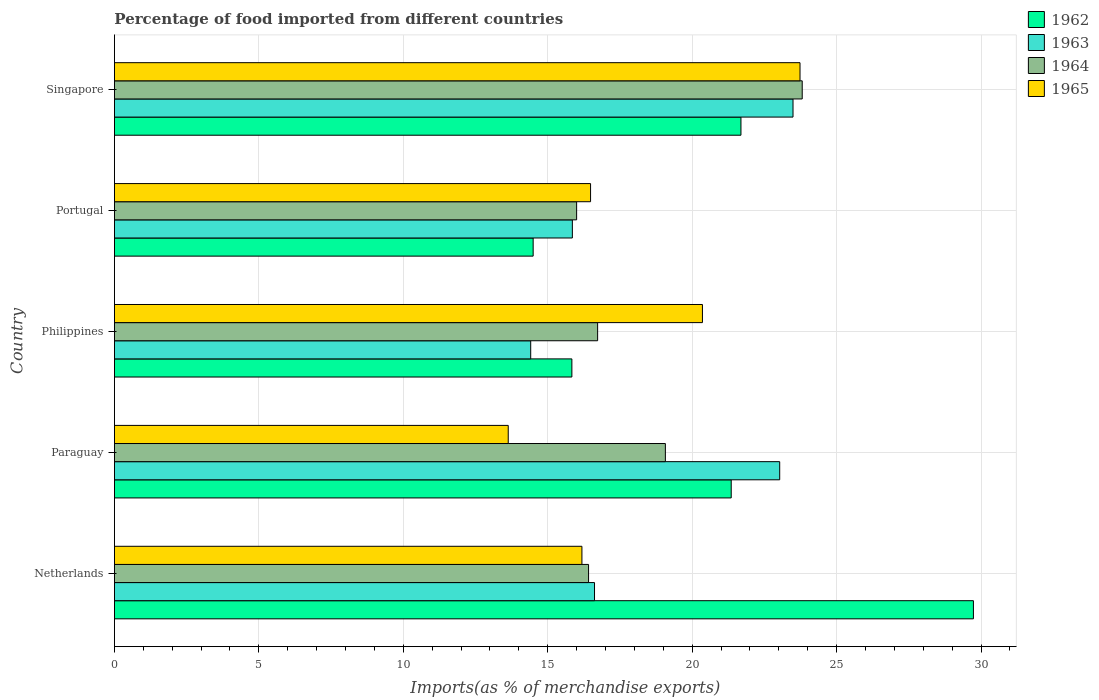How many different coloured bars are there?
Keep it short and to the point. 4. Are the number of bars per tick equal to the number of legend labels?
Offer a terse response. Yes. How many bars are there on the 4th tick from the bottom?
Provide a short and direct response. 4. In how many cases, is the number of bars for a given country not equal to the number of legend labels?
Your response must be concise. 0. What is the percentage of imports to different countries in 1964 in Netherlands?
Ensure brevity in your answer.  16.41. Across all countries, what is the maximum percentage of imports to different countries in 1965?
Offer a very short reply. 23.73. Across all countries, what is the minimum percentage of imports to different countries in 1964?
Ensure brevity in your answer.  16. In which country was the percentage of imports to different countries in 1963 maximum?
Give a very brief answer. Singapore. What is the total percentage of imports to different countries in 1964 in the graph?
Your answer should be compact. 92.02. What is the difference between the percentage of imports to different countries in 1962 in Paraguay and that in Portugal?
Your response must be concise. 6.86. What is the difference between the percentage of imports to different countries in 1965 in Paraguay and the percentage of imports to different countries in 1964 in Philippines?
Keep it short and to the point. -3.09. What is the average percentage of imports to different countries in 1964 per country?
Give a very brief answer. 18.4. What is the difference between the percentage of imports to different countries in 1964 and percentage of imports to different countries in 1965 in Netherlands?
Give a very brief answer. 0.23. What is the ratio of the percentage of imports to different countries in 1965 in Portugal to that in Singapore?
Offer a very short reply. 0.69. Is the difference between the percentage of imports to different countries in 1964 in Philippines and Portugal greater than the difference between the percentage of imports to different countries in 1965 in Philippines and Portugal?
Offer a terse response. No. What is the difference between the highest and the second highest percentage of imports to different countries in 1964?
Ensure brevity in your answer.  4.74. What is the difference between the highest and the lowest percentage of imports to different countries in 1965?
Provide a short and direct response. 10.1. Is the sum of the percentage of imports to different countries in 1965 in Netherlands and Portugal greater than the maximum percentage of imports to different countries in 1963 across all countries?
Provide a succinct answer. Yes. What does the 1st bar from the top in Portugal represents?
Your response must be concise. 1965. What does the 4th bar from the bottom in Singapore represents?
Your answer should be compact. 1965. Is it the case that in every country, the sum of the percentage of imports to different countries in 1964 and percentage of imports to different countries in 1965 is greater than the percentage of imports to different countries in 1962?
Offer a very short reply. Yes. Are all the bars in the graph horizontal?
Provide a short and direct response. Yes. Are the values on the major ticks of X-axis written in scientific E-notation?
Offer a very short reply. No. Does the graph contain any zero values?
Your answer should be very brief. No. Does the graph contain grids?
Provide a short and direct response. Yes. Where does the legend appear in the graph?
Provide a short and direct response. Top right. How many legend labels are there?
Give a very brief answer. 4. How are the legend labels stacked?
Provide a short and direct response. Vertical. What is the title of the graph?
Provide a short and direct response. Percentage of food imported from different countries. What is the label or title of the X-axis?
Ensure brevity in your answer.  Imports(as % of merchandise exports). What is the label or title of the Y-axis?
Give a very brief answer. Country. What is the Imports(as % of merchandise exports) in 1962 in Netherlands?
Ensure brevity in your answer.  29.73. What is the Imports(as % of merchandise exports) in 1963 in Netherlands?
Provide a short and direct response. 16.62. What is the Imports(as % of merchandise exports) of 1964 in Netherlands?
Keep it short and to the point. 16.41. What is the Imports(as % of merchandise exports) in 1965 in Netherlands?
Keep it short and to the point. 16.18. What is the Imports(as % of merchandise exports) in 1962 in Paraguay?
Your answer should be very brief. 21.35. What is the Imports(as % of merchandise exports) in 1963 in Paraguay?
Make the answer very short. 23.03. What is the Imports(as % of merchandise exports) of 1964 in Paraguay?
Provide a succinct answer. 19.07. What is the Imports(as % of merchandise exports) in 1965 in Paraguay?
Give a very brief answer. 13.63. What is the Imports(as % of merchandise exports) in 1962 in Philippines?
Your answer should be very brief. 15.83. What is the Imports(as % of merchandise exports) in 1963 in Philippines?
Offer a terse response. 14.41. What is the Imports(as % of merchandise exports) of 1964 in Philippines?
Your answer should be very brief. 16.73. What is the Imports(as % of merchandise exports) of 1965 in Philippines?
Give a very brief answer. 20.35. What is the Imports(as % of merchandise exports) in 1962 in Portugal?
Your answer should be compact. 14.49. What is the Imports(as % of merchandise exports) of 1963 in Portugal?
Provide a succinct answer. 15.85. What is the Imports(as % of merchandise exports) of 1964 in Portugal?
Your answer should be very brief. 16. What is the Imports(as % of merchandise exports) in 1965 in Portugal?
Your answer should be compact. 16.48. What is the Imports(as % of merchandise exports) in 1962 in Singapore?
Provide a short and direct response. 21.69. What is the Imports(as % of merchandise exports) in 1963 in Singapore?
Ensure brevity in your answer.  23.49. What is the Imports(as % of merchandise exports) of 1964 in Singapore?
Your answer should be very brief. 23.81. What is the Imports(as % of merchandise exports) in 1965 in Singapore?
Offer a terse response. 23.73. Across all countries, what is the maximum Imports(as % of merchandise exports) of 1962?
Provide a succinct answer. 29.73. Across all countries, what is the maximum Imports(as % of merchandise exports) of 1963?
Offer a very short reply. 23.49. Across all countries, what is the maximum Imports(as % of merchandise exports) of 1964?
Offer a very short reply. 23.81. Across all countries, what is the maximum Imports(as % of merchandise exports) in 1965?
Keep it short and to the point. 23.73. Across all countries, what is the minimum Imports(as % of merchandise exports) of 1962?
Your response must be concise. 14.49. Across all countries, what is the minimum Imports(as % of merchandise exports) of 1963?
Give a very brief answer. 14.41. Across all countries, what is the minimum Imports(as % of merchandise exports) of 1964?
Give a very brief answer. 16. Across all countries, what is the minimum Imports(as % of merchandise exports) in 1965?
Keep it short and to the point. 13.63. What is the total Imports(as % of merchandise exports) of 1962 in the graph?
Your answer should be very brief. 103.1. What is the total Imports(as % of merchandise exports) in 1963 in the graph?
Provide a short and direct response. 93.4. What is the total Imports(as % of merchandise exports) in 1964 in the graph?
Give a very brief answer. 92.02. What is the total Imports(as % of merchandise exports) in 1965 in the graph?
Offer a terse response. 90.38. What is the difference between the Imports(as % of merchandise exports) of 1962 in Netherlands and that in Paraguay?
Give a very brief answer. 8.38. What is the difference between the Imports(as % of merchandise exports) in 1963 in Netherlands and that in Paraguay?
Ensure brevity in your answer.  -6.41. What is the difference between the Imports(as % of merchandise exports) of 1964 in Netherlands and that in Paraguay?
Provide a succinct answer. -2.66. What is the difference between the Imports(as % of merchandise exports) of 1965 in Netherlands and that in Paraguay?
Offer a very short reply. 2.55. What is the difference between the Imports(as % of merchandise exports) of 1962 in Netherlands and that in Philippines?
Give a very brief answer. 13.9. What is the difference between the Imports(as % of merchandise exports) in 1963 in Netherlands and that in Philippines?
Your answer should be compact. 2.21. What is the difference between the Imports(as % of merchandise exports) of 1964 in Netherlands and that in Philippines?
Provide a succinct answer. -0.31. What is the difference between the Imports(as % of merchandise exports) in 1965 in Netherlands and that in Philippines?
Offer a very short reply. -4.17. What is the difference between the Imports(as % of merchandise exports) in 1962 in Netherlands and that in Portugal?
Provide a short and direct response. 15.24. What is the difference between the Imports(as % of merchandise exports) in 1963 in Netherlands and that in Portugal?
Make the answer very short. 0.77. What is the difference between the Imports(as % of merchandise exports) of 1964 in Netherlands and that in Portugal?
Provide a succinct answer. 0.41. What is the difference between the Imports(as % of merchandise exports) in 1965 in Netherlands and that in Portugal?
Your answer should be compact. -0.3. What is the difference between the Imports(as % of merchandise exports) in 1962 in Netherlands and that in Singapore?
Provide a short and direct response. 8.05. What is the difference between the Imports(as % of merchandise exports) in 1963 in Netherlands and that in Singapore?
Provide a short and direct response. -6.87. What is the difference between the Imports(as % of merchandise exports) in 1964 in Netherlands and that in Singapore?
Your answer should be compact. -7.4. What is the difference between the Imports(as % of merchandise exports) in 1965 in Netherlands and that in Singapore?
Your answer should be very brief. -7.55. What is the difference between the Imports(as % of merchandise exports) of 1962 in Paraguay and that in Philippines?
Offer a terse response. 5.52. What is the difference between the Imports(as % of merchandise exports) of 1963 in Paraguay and that in Philippines?
Keep it short and to the point. 8.62. What is the difference between the Imports(as % of merchandise exports) of 1964 in Paraguay and that in Philippines?
Your response must be concise. 2.35. What is the difference between the Imports(as % of merchandise exports) in 1965 in Paraguay and that in Philippines?
Keep it short and to the point. -6.72. What is the difference between the Imports(as % of merchandise exports) in 1962 in Paraguay and that in Portugal?
Ensure brevity in your answer.  6.86. What is the difference between the Imports(as % of merchandise exports) of 1963 in Paraguay and that in Portugal?
Offer a terse response. 7.18. What is the difference between the Imports(as % of merchandise exports) of 1964 in Paraguay and that in Portugal?
Provide a succinct answer. 3.07. What is the difference between the Imports(as % of merchandise exports) of 1965 in Paraguay and that in Portugal?
Give a very brief answer. -2.85. What is the difference between the Imports(as % of merchandise exports) in 1962 in Paraguay and that in Singapore?
Give a very brief answer. -0.34. What is the difference between the Imports(as % of merchandise exports) of 1963 in Paraguay and that in Singapore?
Provide a succinct answer. -0.46. What is the difference between the Imports(as % of merchandise exports) in 1964 in Paraguay and that in Singapore?
Make the answer very short. -4.74. What is the difference between the Imports(as % of merchandise exports) of 1965 in Paraguay and that in Singapore?
Give a very brief answer. -10.1. What is the difference between the Imports(as % of merchandise exports) in 1962 in Philippines and that in Portugal?
Provide a succinct answer. 1.34. What is the difference between the Imports(as % of merchandise exports) of 1963 in Philippines and that in Portugal?
Offer a terse response. -1.44. What is the difference between the Imports(as % of merchandise exports) of 1964 in Philippines and that in Portugal?
Your response must be concise. 0.73. What is the difference between the Imports(as % of merchandise exports) in 1965 in Philippines and that in Portugal?
Provide a succinct answer. 3.87. What is the difference between the Imports(as % of merchandise exports) of 1962 in Philippines and that in Singapore?
Offer a very short reply. -5.85. What is the difference between the Imports(as % of merchandise exports) of 1963 in Philippines and that in Singapore?
Offer a very short reply. -9.08. What is the difference between the Imports(as % of merchandise exports) in 1964 in Philippines and that in Singapore?
Offer a terse response. -7.08. What is the difference between the Imports(as % of merchandise exports) of 1965 in Philippines and that in Singapore?
Give a very brief answer. -3.38. What is the difference between the Imports(as % of merchandise exports) of 1962 in Portugal and that in Singapore?
Provide a short and direct response. -7.19. What is the difference between the Imports(as % of merchandise exports) in 1963 in Portugal and that in Singapore?
Your answer should be compact. -7.64. What is the difference between the Imports(as % of merchandise exports) of 1964 in Portugal and that in Singapore?
Keep it short and to the point. -7.81. What is the difference between the Imports(as % of merchandise exports) of 1965 in Portugal and that in Singapore?
Your answer should be very brief. -7.25. What is the difference between the Imports(as % of merchandise exports) of 1962 in Netherlands and the Imports(as % of merchandise exports) of 1963 in Paraguay?
Your answer should be very brief. 6.71. What is the difference between the Imports(as % of merchandise exports) in 1962 in Netherlands and the Imports(as % of merchandise exports) in 1964 in Paraguay?
Provide a short and direct response. 10.66. What is the difference between the Imports(as % of merchandise exports) of 1962 in Netherlands and the Imports(as % of merchandise exports) of 1965 in Paraguay?
Provide a succinct answer. 16.1. What is the difference between the Imports(as % of merchandise exports) of 1963 in Netherlands and the Imports(as % of merchandise exports) of 1964 in Paraguay?
Your answer should be compact. -2.45. What is the difference between the Imports(as % of merchandise exports) in 1963 in Netherlands and the Imports(as % of merchandise exports) in 1965 in Paraguay?
Offer a very short reply. 2.99. What is the difference between the Imports(as % of merchandise exports) in 1964 in Netherlands and the Imports(as % of merchandise exports) in 1965 in Paraguay?
Provide a short and direct response. 2.78. What is the difference between the Imports(as % of merchandise exports) in 1962 in Netherlands and the Imports(as % of merchandise exports) in 1963 in Philippines?
Ensure brevity in your answer.  15.32. What is the difference between the Imports(as % of merchandise exports) of 1962 in Netherlands and the Imports(as % of merchandise exports) of 1964 in Philippines?
Ensure brevity in your answer.  13.01. What is the difference between the Imports(as % of merchandise exports) of 1962 in Netherlands and the Imports(as % of merchandise exports) of 1965 in Philippines?
Offer a terse response. 9.38. What is the difference between the Imports(as % of merchandise exports) in 1963 in Netherlands and the Imports(as % of merchandise exports) in 1964 in Philippines?
Offer a terse response. -0.11. What is the difference between the Imports(as % of merchandise exports) of 1963 in Netherlands and the Imports(as % of merchandise exports) of 1965 in Philippines?
Offer a terse response. -3.74. What is the difference between the Imports(as % of merchandise exports) in 1964 in Netherlands and the Imports(as % of merchandise exports) in 1965 in Philippines?
Offer a terse response. -3.94. What is the difference between the Imports(as % of merchandise exports) of 1962 in Netherlands and the Imports(as % of merchandise exports) of 1963 in Portugal?
Offer a terse response. 13.88. What is the difference between the Imports(as % of merchandise exports) of 1962 in Netherlands and the Imports(as % of merchandise exports) of 1964 in Portugal?
Your answer should be very brief. 13.74. What is the difference between the Imports(as % of merchandise exports) in 1962 in Netherlands and the Imports(as % of merchandise exports) in 1965 in Portugal?
Your answer should be compact. 13.25. What is the difference between the Imports(as % of merchandise exports) in 1963 in Netherlands and the Imports(as % of merchandise exports) in 1964 in Portugal?
Offer a terse response. 0.62. What is the difference between the Imports(as % of merchandise exports) of 1963 in Netherlands and the Imports(as % of merchandise exports) of 1965 in Portugal?
Provide a short and direct response. 0.14. What is the difference between the Imports(as % of merchandise exports) in 1964 in Netherlands and the Imports(as % of merchandise exports) in 1965 in Portugal?
Your response must be concise. -0.07. What is the difference between the Imports(as % of merchandise exports) in 1962 in Netherlands and the Imports(as % of merchandise exports) in 1963 in Singapore?
Give a very brief answer. 6.25. What is the difference between the Imports(as % of merchandise exports) of 1962 in Netherlands and the Imports(as % of merchandise exports) of 1964 in Singapore?
Make the answer very short. 5.93. What is the difference between the Imports(as % of merchandise exports) of 1962 in Netherlands and the Imports(as % of merchandise exports) of 1965 in Singapore?
Provide a succinct answer. 6. What is the difference between the Imports(as % of merchandise exports) of 1963 in Netherlands and the Imports(as % of merchandise exports) of 1964 in Singapore?
Your answer should be compact. -7.19. What is the difference between the Imports(as % of merchandise exports) of 1963 in Netherlands and the Imports(as % of merchandise exports) of 1965 in Singapore?
Make the answer very short. -7.11. What is the difference between the Imports(as % of merchandise exports) in 1964 in Netherlands and the Imports(as % of merchandise exports) in 1965 in Singapore?
Make the answer very short. -7.32. What is the difference between the Imports(as % of merchandise exports) of 1962 in Paraguay and the Imports(as % of merchandise exports) of 1963 in Philippines?
Provide a succinct answer. 6.94. What is the difference between the Imports(as % of merchandise exports) of 1962 in Paraguay and the Imports(as % of merchandise exports) of 1964 in Philippines?
Provide a succinct answer. 4.62. What is the difference between the Imports(as % of merchandise exports) of 1963 in Paraguay and the Imports(as % of merchandise exports) of 1964 in Philippines?
Make the answer very short. 6.3. What is the difference between the Imports(as % of merchandise exports) in 1963 in Paraguay and the Imports(as % of merchandise exports) in 1965 in Philippines?
Your response must be concise. 2.67. What is the difference between the Imports(as % of merchandise exports) in 1964 in Paraguay and the Imports(as % of merchandise exports) in 1965 in Philippines?
Your response must be concise. -1.28. What is the difference between the Imports(as % of merchandise exports) in 1962 in Paraguay and the Imports(as % of merchandise exports) in 1963 in Portugal?
Offer a terse response. 5.5. What is the difference between the Imports(as % of merchandise exports) of 1962 in Paraguay and the Imports(as % of merchandise exports) of 1964 in Portugal?
Offer a very short reply. 5.35. What is the difference between the Imports(as % of merchandise exports) of 1962 in Paraguay and the Imports(as % of merchandise exports) of 1965 in Portugal?
Your response must be concise. 4.87. What is the difference between the Imports(as % of merchandise exports) in 1963 in Paraguay and the Imports(as % of merchandise exports) in 1964 in Portugal?
Make the answer very short. 7.03. What is the difference between the Imports(as % of merchandise exports) in 1963 in Paraguay and the Imports(as % of merchandise exports) in 1965 in Portugal?
Ensure brevity in your answer.  6.55. What is the difference between the Imports(as % of merchandise exports) of 1964 in Paraguay and the Imports(as % of merchandise exports) of 1965 in Portugal?
Offer a very short reply. 2.59. What is the difference between the Imports(as % of merchandise exports) of 1962 in Paraguay and the Imports(as % of merchandise exports) of 1963 in Singapore?
Give a very brief answer. -2.14. What is the difference between the Imports(as % of merchandise exports) in 1962 in Paraguay and the Imports(as % of merchandise exports) in 1964 in Singapore?
Ensure brevity in your answer.  -2.46. What is the difference between the Imports(as % of merchandise exports) of 1962 in Paraguay and the Imports(as % of merchandise exports) of 1965 in Singapore?
Give a very brief answer. -2.38. What is the difference between the Imports(as % of merchandise exports) of 1963 in Paraguay and the Imports(as % of merchandise exports) of 1964 in Singapore?
Your answer should be compact. -0.78. What is the difference between the Imports(as % of merchandise exports) of 1963 in Paraguay and the Imports(as % of merchandise exports) of 1965 in Singapore?
Your response must be concise. -0.7. What is the difference between the Imports(as % of merchandise exports) in 1964 in Paraguay and the Imports(as % of merchandise exports) in 1965 in Singapore?
Your answer should be compact. -4.66. What is the difference between the Imports(as % of merchandise exports) of 1962 in Philippines and the Imports(as % of merchandise exports) of 1963 in Portugal?
Your answer should be compact. -0.02. What is the difference between the Imports(as % of merchandise exports) of 1962 in Philippines and the Imports(as % of merchandise exports) of 1964 in Portugal?
Provide a short and direct response. -0.16. What is the difference between the Imports(as % of merchandise exports) in 1962 in Philippines and the Imports(as % of merchandise exports) in 1965 in Portugal?
Make the answer very short. -0.65. What is the difference between the Imports(as % of merchandise exports) of 1963 in Philippines and the Imports(as % of merchandise exports) of 1964 in Portugal?
Keep it short and to the point. -1.59. What is the difference between the Imports(as % of merchandise exports) of 1963 in Philippines and the Imports(as % of merchandise exports) of 1965 in Portugal?
Offer a very short reply. -2.07. What is the difference between the Imports(as % of merchandise exports) in 1964 in Philippines and the Imports(as % of merchandise exports) in 1965 in Portugal?
Offer a terse response. 0.24. What is the difference between the Imports(as % of merchandise exports) in 1962 in Philippines and the Imports(as % of merchandise exports) in 1963 in Singapore?
Your response must be concise. -7.65. What is the difference between the Imports(as % of merchandise exports) of 1962 in Philippines and the Imports(as % of merchandise exports) of 1964 in Singapore?
Make the answer very short. -7.97. What is the difference between the Imports(as % of merchandise exports) of 1962 in Philippines and the Imports(as % of merchandise exports) of 1965 in Singapore?
Your answer should be very brief. -7.9. What is the difference between the Imports(as % of merchandise exports) in 1963 in Philippines and the Imports(as % of merchandise exports) in 1964 in Singapore?
Your response must be concise. -9.4. What is the difference between the Imports(as % of merchandise exports) in 1963 in Philippines and the Imports(as % of merchandise exports) in 1965 in Singapore?
Provide a succinct answer. -9.32. What is the difference between the Imports(as % of merchandise exports) in 1964 in Philippines and the Imports(as % of merchandise exports) in 1965 in Singapore?
Offer a terse response. -7.01. What is the difference between the Imports(as % of merchandise exports) of 1962 in Portugal and the Imports(as % of merchandise exports) of 1963 in Singapore?
Keep it short and to the point. -8.99. What is the difference between the Imports(as % of merchandise exports) of 1962 in Portugal and the Imports(as % of merchandise exports) of 1964 in Singapore?
Your response must be concise. -9.31. What is the difference between the Imports(as % of merchandise exports) of 1962 in Portugal and the Imports(as % of merchandise exports) of 1965 in Singapore?
Your answer should be compact. -9.24. What is the difference between the Imports(as % of merchandise exports) of 1963 in Portugal and the Imports(as % of merchandise exports) of 1964 in Singapore?
Offer a terse response. -7.96. What is the difference between the Imports(as % of merchandise exports) of 1963 in Portugal and the Imports(as % of merchandise exports) of 1965 in Singapore?
Make the answer very short. -7.88. What is the difference between the Imports(as % of merchandise exports) in 1964 in Portugal and the Imports(as % of merchandise exports) in 1965 in Singapore?
Offer a terse response. -7.73. What is the average Imports(as % of merchandise exports) in 1962 per country?
Offer a very short reply. 20.62. What is the average Imports(as % of merchandise exports) of 1963 per country?
Ensure brevity in your answer.  18.68. What is the average Imports(as % of merchandise exports) of 1964 per country?
Make the answer very short. 18.4. What is the average Imports(as % of merchandise exports) of 1965 per country?
Your answer should be compact. 18.08. What is the difference between the Imports(as % of merchandise exports) of 1962 and Imports(as % of merchandise exports) of 1963 in Netherlands?
Provide a short and direct response. 13.12. What is the difference between the Imports(as % of merchandise exports) in 1962 and Imports(as % of merchandise exports) in 1964 in Netherlands?
Give a very brief answer. 13.32. What is the difference between the Imports(as % of merchandise exports) in 1962 and Imports(as % of merchandise exports) in 1965 in Netherlands?
Your answer should be very brief. 13.55. What is the difference between the Imports(as % of merchandise exports) of 1963 and Imports(as % of merchandise exports) of 1964 in Netherlands?
Keep it short and to the point. 0.21. What is the difference between the Imports(as % of merchandise exports) in 1963 and Imports(as % of merchandise exports) in 1965 in Netherlands?
Your response must be concise. 0.44. What is the difference between the Imports(as % of merchandise exports) in 1964 and Imports(as % of merchandise exports) in 1965 in Netherlands?
Provide a succinct answer. 0.23. What is the difference between the Imports(as % of merchandise exports) in 1962 and Imports(as % of merchandise exports) in 1963 in Paraguay?
Your answer should be very brief. -1.68. What is the difference between the Imports(as % of merchandise exports) of 1962 and Imports(as % of merchandise exports) of 1964 in Paraguay?
Offer a terse response. 2.28. What is the difference between the Imports(as % of merchandise exports) of 1962 and Imports(as % of merchandise exports) of 1965 in Paraguay?
Your answer should be very brief. 7.72. What is the difference between the Imports(as % of merchandise exports) of 1963 and Imports(as % of merchandise exports) of 1964 in Paraguay?
Give a very brief answer. 3.96. What is the difference between the Imports(as % of merchandise exports) in 1963 and Imports(as % of merchandise exports) in 1965 in Paraguay?
Keep it short and to the point. 9.4. What is the difference between the Imports(as % of merchandise exports) in 1964 and Imports(as % of merchandise exports) in 1965 in Paraguay?
Keep it short and to the point. 5.44. What is the difference between the Imports(as % of merchandise exports) of 1962 and Imports(as % of merchandise exports) of 1963 in Philippines?
Provide a succinct answer. 1.43. What is the difference between the Imports(as % of merchandise exports) of 1962 and Imports(as % of merchandise exports) of 1964 in Philippines?
Your answer should be very brief. -0.89. What is the difference between the Imports(as % of merchandise exports) of 1962 and Imports(as % of merchandise exports) of 1965 in Philippines?
Provide a short and direct response. -4.52. What is the difference between the Imports(as % of merchandise exports) in 1963 and Imports(as % of merchandise exports) in 1964 in Philippines?
Ensure brevity in your answer.  -2.32. What is the difference between the Imports(as % of merchandise exports) in 1963 and Imports(as % of merchandise exports) in 1965 in Philippines?
Keep it short and to the point. -5.94. What is the difference between the Imports(as % of merchandise exports) in 1964 and Imports(as % of merchandise exports) in 1965 in Philippines?
Your response must be concise. -3.63. What is the difference between the Imports(as % of merchandise exports) in 1962 and Imports(as % of merchandise exports) in 1963 in Portugal?
Your answer should be very brief. -1.36. What is the difference between the Imports(as % of merchandise exports) of 1962 and Imports(as % of merchandise exports) of 1964 in Portugal?
Offer a very short reply. -1.5. What is the difference between the Imports(as % of merchandise exports) in 1962 and Imports(as % of merchandise exports) in 1965 in Portugal?
Your answer should be very brief. -1.99. What is the difference between the Imports(as % of merchandise exports) of 1963 and Imports(as % of merchandise exports) of 1964 in Portugal?
Your answer should be compact. -0.15. What is the difference between the Imports(as % of merchandise exports) of 1963 and Imports(as % of merchandise exports) of 1965 in Portugal?
Keep it short and to the point. -0.63. What is the difference between the Imports(as % of merchandise exports) of 1964 and Imports(as % of merchandise exports) of 1965 in Portugal?
Make the answer very short. -0.48. What is the difference between the Imports(as % of merchandise exports) in 1962 and Imports(as % of merchandise exports) in 1963 in Singapore?
Offer a very short reply. -1.8. What is the difference between the Imports(as % of merchandise exports) of 1962 and Imports(as % of merchandise exports) of 1964 in Singapore?
Your response must be concise. -2.12. What is the difference between the Imports(as % of merchandise exports) of 1962 and Imports(as % of merchandise exports) of 1965 in Singapore?
Your answer should be compact. -2.04. What is the difference between the Imports(as % of merchandise exports) in 1963 and Imports(as % of merchandise exports) in 1964 in Singapore?
Give a very brief answer. -0.32. What is the difference between the Imports(as % of merchandise exports) in 1963 and Imports(as % of merchandise exports) in 1965 in Singapore?
Offer a very short reply. -0.24. What is the difference between the Imports(as % of merchandise exports) of 1964 and Imports(as % of merchandise exports) of 1965 in Singapore?
Offer a very short reply. 0.08. What is the ratio of the Imports(as % of merchandise exports) in 1962 in Netherlands to that in Paraguay?
Offer a very short reply. 1.39. What is the ratio of the Imports(as % of merchandise exports) of 1963 in Netherlands to that in Paraguay?
Give a very brief answer. 0.72. What is the ratio of the Imports(as % of merchandise exports) of 1964 in Netherlands to that in Paraguay?
Your response must be concise. 0.86. What is the ratio of the Imports(as % of merchandise exports) of 1965 in Netherlands to that in Paraguay?
Your answer should be compact. 1.19. What is the ratio of the Imports(as % of merchandise exports) in 1962 in Netherlands to that in Philippines?
Provide a succinct answer. 1.88. What is the ratio of the Imports(as % of merchandise exports) in 1963 in Netherlands to that in Philippines?
Offer a terse response. 1.15. What is the ratio of the Imports(as % of merchandise exports) of 1964 in Netherlands to that in Philippines?
Your answer should be compact. 0.98. What is the ratio of the Imports(as % of merchandise exports) in 1965 in Netherlands to that in Philippines?
Provide a succinct answer. 0.8. What is the ratio of the Imports(as % of merchandise exports) in 1962 in Netherlands to that in Portugal?
Offer a very short reply. 2.05. What is the ratio of the Imports(as % of merchandise exports) in 1963 in Netherlands to that in Portugal?
Make the answer very short. 1.05. What is the ratio of the Imports(as % of merchandise exports) of 1964 in Netherlands to that in Portugal?
Provide a short and direct response. 1.03. What is the ratio of the Imports(as % of merchandise exports) in 1965 in Netherlands to that in Portugal?
Provide a short and direct response. 0.98. What is the ratio of the Imports(as % of merchandise exports) of 1962 in Netherlands to that in Singapore?
Provide a short and direct response. 1.37. What is the ratio of the Imports(as % of merchandise exports) in 1963 in Netherlands to that in Singapore?
Make the answer very short. 0.71. What is the ratio of the Imports(as % of merchandise exports) of 1964 in Netherlands to that in Singapore?
Your answer should be compact. 0.69. What is the ratio of the Imports(as % of merchandise exports) of 1965 in Netherlands to that in Singapore?
Provide a succinct answer. 0.68. What is the ratio of the Imports(as % of merchandise exports) in 1962 in Paraguay to that in Philippines?
Keep it short and to the point. 1.35. What is the ratio of the Imports(as % of merchandise exports) of 1963 in Paraguay to that in Philippines?
Make the answer very short. 1.6. What is the ratio of the Imports(as % of merchandise exports) of 1964 in Paraguay to that in Philippines?
Offer a terse response. 1.14. What is the ratio of the Imports(as % of merchandise exports) of 1965 in Paraguay to that in Philippines?
Ensure brevity in your answer.  0.67. What is the ratio of the Imports(as % of merchandise exports) of 1962 in Paraguay to that in Portugal?
Ensure brevity in your answer.  1.47. What is the ratio of the Imports(as % of merchandise exports) of 1963 in Paraguay to that in Portugal?
Your answer should be very brief. 1.45. What is the ratio of the Imports(as % of merchandise exports) of 1964 in Paraguay to that in Portugal?
Offer a terse response. 1.19. What is the ratio of the Imports(as % of merchandise exports) of 1965 in Paraguay to that in Portugal?
Offer a very short reply. 0.83. What is the ratio of the Imports(as % of merchandise exports) of 1962 in Paraguay to that in Singapore?
Give a very brief answer. 0.98. What is the ratio of the Imports(as % of merchandise exports) in 1963 in Paraguay to that in Singapore?
Give a very brief answer. 0.98. What is the ratio of the Imports(as % of merchandise exports) of 1964 in Paraguay to that in Singapore?
Ensure brevity in your answer.  0.8. What is the ratio of the Imports(as % of merchandise exports) in 1965 in Paraguay to that in Singapore?
Offer a terse response. 0.57. What is the ratio of the Imports(as % of merchandise exports) of 1962 in Philippines to that in Portugal?
Keep it short and to the point. 1.09. What is the ratio of the Imports(as % of merchandise exports) in 1963 in Philippines to that in Portugal?
Offer a very short reply. 0.91. What is the ratio of the Imports(as % of merchandise exports) of 1964 in Philippines to that in Portugal?
Provide a succinct answer. 1.05. What is the ratio of the Imports(as % of merchandise exports) of 1965 in Philippines to that in Portugal?
Your answer should be very brief. 1.24. What is the ratio of the Imports(as % of merchandise exports) of 1962 in Philippines to that in Singapore?
Give a very brief answer. 0.73. What is the ratio of the Imports(as % of merchandise exports) in 1963 in Philippines to that in Singapore?
Your answer should be compact. 0.61. What is the ratio of the Imports(as % of merchandise exports) in 1964 in Philippines to that in Singapore?
Offer a terse response. 0.7. What is the ratio of the Imports(as % of merchandise exports) of 1965 in Philippines to that in Singapore?
Ensure brevity in your answer.  0.86. What is the ratio of the Imports(as % of merchandise exports) of 1962 in Portugal to that in Singapore?
Provide a short and direct response. 0.67. What is the ratio of the Imports(as % of merchandise exports) of 1963 in Portugal to that in Singapore?
Your response must be concise. 0.67. What is the ratio of the Imports(as % of merchandise exports) in 1964 in Portugal to that in Singapore?
Give a very brief answer. 0.67. What is the ratio of the Imports(as % of merchandise exports) of 1965 in Portugal to that in Singapore?
Your answer should be compact. 0.69. What is the difference between the highest and the second highest Imports(as % of merchandise exports) in 1962?
Your response must be concise. 8.05. What is the difference between the highest and the second highest Imports(as % of merchandise exports) of 1963?
Your answer should be very brief. 0.46. What is the difference between the highest and the second highest Imports(as % of merchandise exports) in 1964?
Ensure brevity in your answer.  4.74. What is the difference between the highest and the second highest Imports(as % of merchandise exports) in 1965?
Your response must be concise. 3.38. What is the difference between the highest and the lowest Imports(as % of merchandise exports) of 1962?
Provide a short and direct response. 15.24. What is the difference between the highest and the lowest Imports(as % of merchandise exports) in 1963?
Provide a succinct answer. 9.08. What is the difference between the highest and the lowest Imports(as % of merchandise exports) of 1964?
Provide a short and direct response. 7.81. What is the difference between the highest and the lowest Imports(as % of merchandise exports) in 1965?
Your answer should be very brief. 10.1. 